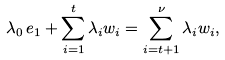<formula> <loc_0><loc_0><loc_500><loc_500>\lambda _ { 0 } \, e _ { 1 } + \sum _ { i = 1 } ^ { t } \lambda _ { i } w _ { i } = \sum _ { i = t + 1 } ^ { \nu } \lambda _ { i } w _ { i } ,</formula> 